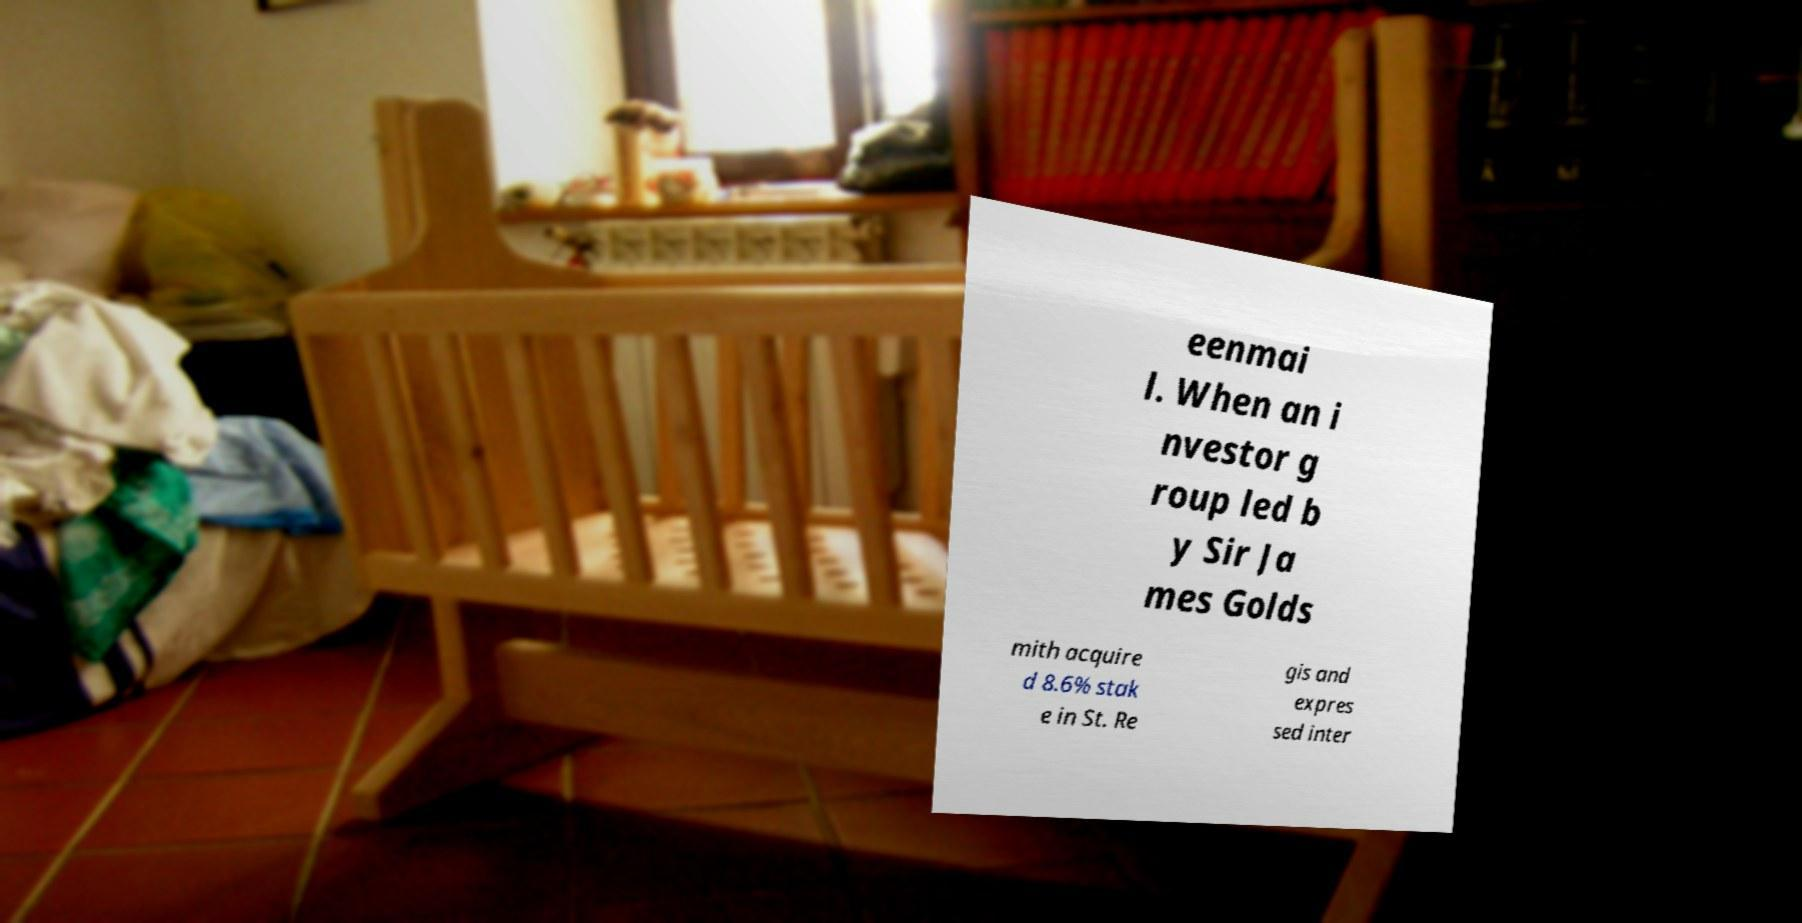For documentation purposes, I need the text within this image transcribed. Could you provide that? eenmai l. When an i nvestor g roup led b y Sir Ja mes Golds mith acquire d 8.6% stak e in St. Re gis and expres sed inter 